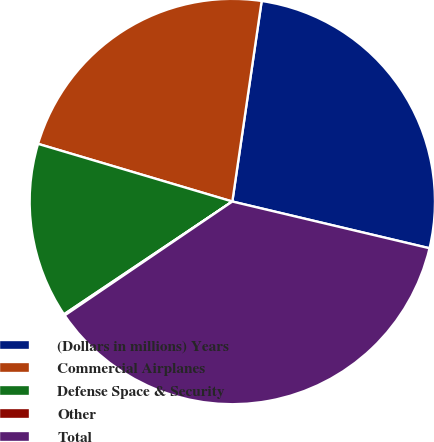<chart> <loc_0><loc_0><loc_500><loc_500><pie_chart><fcel>(Dollars in millions) Years<fcel>Commercial Airplanes<fcel>Defense Space & Security<fcel>Other<fcel>Total<nl><fcel>26.39%<fcel>22.72%<fcel>13.99%<fcel>0.1%<fcel>36.8%<nl></chart> 